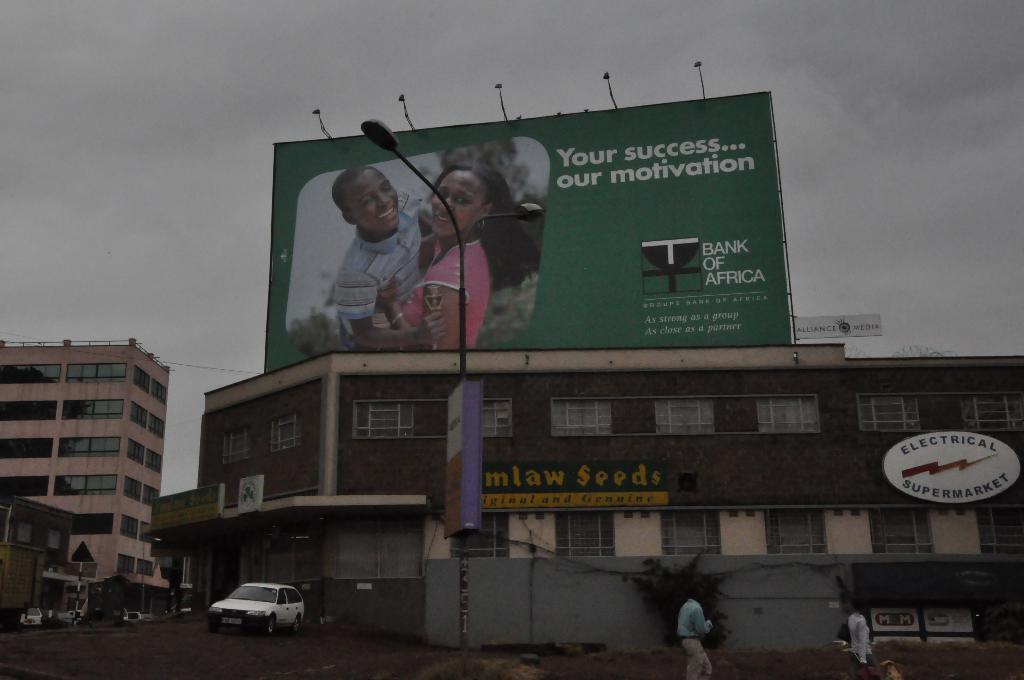Provide a one-sentence caption for the provided image. a billboard that says 'your success... our motivation' on it. 